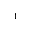Convert formula to latex. <formula><loc_0><loc_0><loc_500><loc_500>^ { 1 }</formula> 